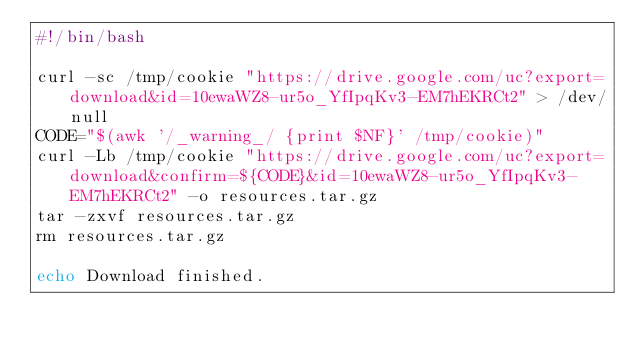Convert code to text. <code><loc_0><loc_0><loc_500><loc_500><_Bash_>#!/bin/bash

curl -sc /tmp/cookie "https://drive.google.com/uc?export=download&id=10ewaWZ8-ur5o_YfIpqKv3-EM7hEKRCt2" > /dev/null
CODE="$(awk '/_warning_/ {print $NF}' /tmp/cookie)"
curl -Lb /tmp/cookie "https://drive.google.com/uc?export=download&confirm=${CODE}&id=10ewaWZ8-ur5o_YfIpqKv3-EM7hEKRCt2" -o resources.tar.gz
tar -zxvf resources.tar.gz
rm resources.tar.gz

echo Download finished.
</code> 